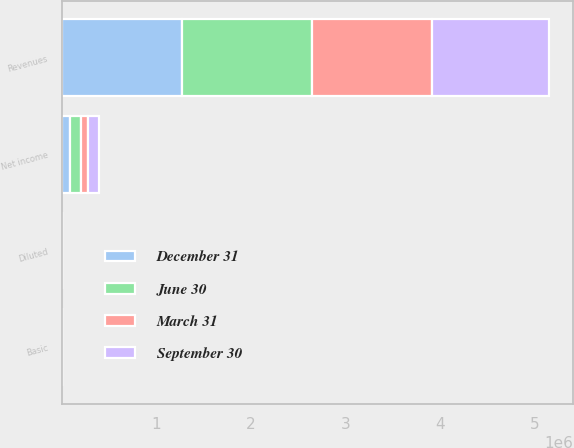<chart> <loc_0><loc_0><loc_500><loc_500><stacked_bar_chart><ecel><fcel>Revenues<fcel>Net income<fcel>Basic<fcel>Diluted<nl><fcel>September 30<fcel>1.23435e+06<fcel>115590<fcel>0.82<fcel>0.78<nl><fcel>December 31<fcel>1.27095e+06<fcel>82184<fcel>0.58<fcel>0.56<nl><fcel>March 31<fcel>1.27973e+06<fcel>76410<fcel>0.55<fcel>0.53<nl><fcel>June 30<fcel>1.37095e+06<fcel>117027<fcel>0.85<fcel>0.82<nl></chart> 